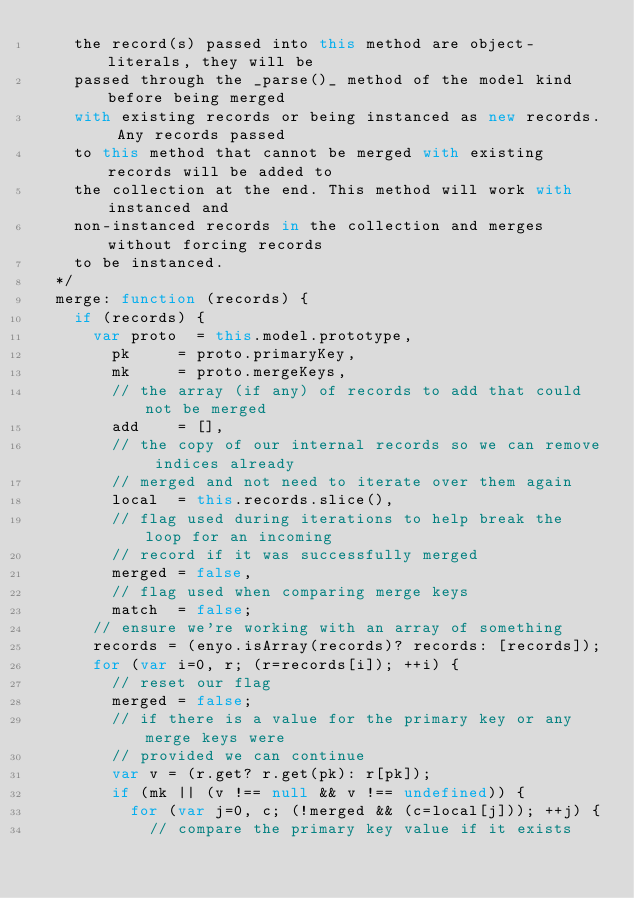<code> <loc_0><loc_0><loc_500><loc_500><_JavaScript_>		the record(s) passed into this method are object-literals, they will be
		passed through the _parse()_ method of the model kind before being merged
		with existing records or being instanced as new records. Any records passed
		to this method that cannot be merged with existing records will be added to
		the collection at the end. This method will work with instanced and
		non-instanced records in the collection and merges without forcing records
		to be instanced.
	*/
	merge: function (records) {
		if (records) {
			var proto  = this.model.prototype,
				pk     = proto.primaryKey,
				mk     = proto.mergeKeys,
				// the array (if any) of records to add that could not be merged
				add    = [],
				// the copy of our internal records so we can remove indices already
				// merged and not need to iterate over them again
				local  = this.records.slice(),
				// flag used during iterations to help break the loop for an incoming
				// record if it was successfully merged
				merged = false,
				// flag used when comparing merge keys
				match  = false;
			// ensure we're working with an array of something
			records = (enyo.isArray(records)? records: [records]);
			for (var i=0, r; (r=records[i]); ++i) {
				// reset our flag
				merged = false;
				// if there is a value for the primary key or any merge keys were
				// provided we can continue
				var v = (r.get? r.get(pk): r[pk]);
				if (mk || (v !== null && v !== undefined)) {
					for (var j=0, c; (!merged && (c=local[j])); ++j) {
						// compare the primary key value if it exists</code> 